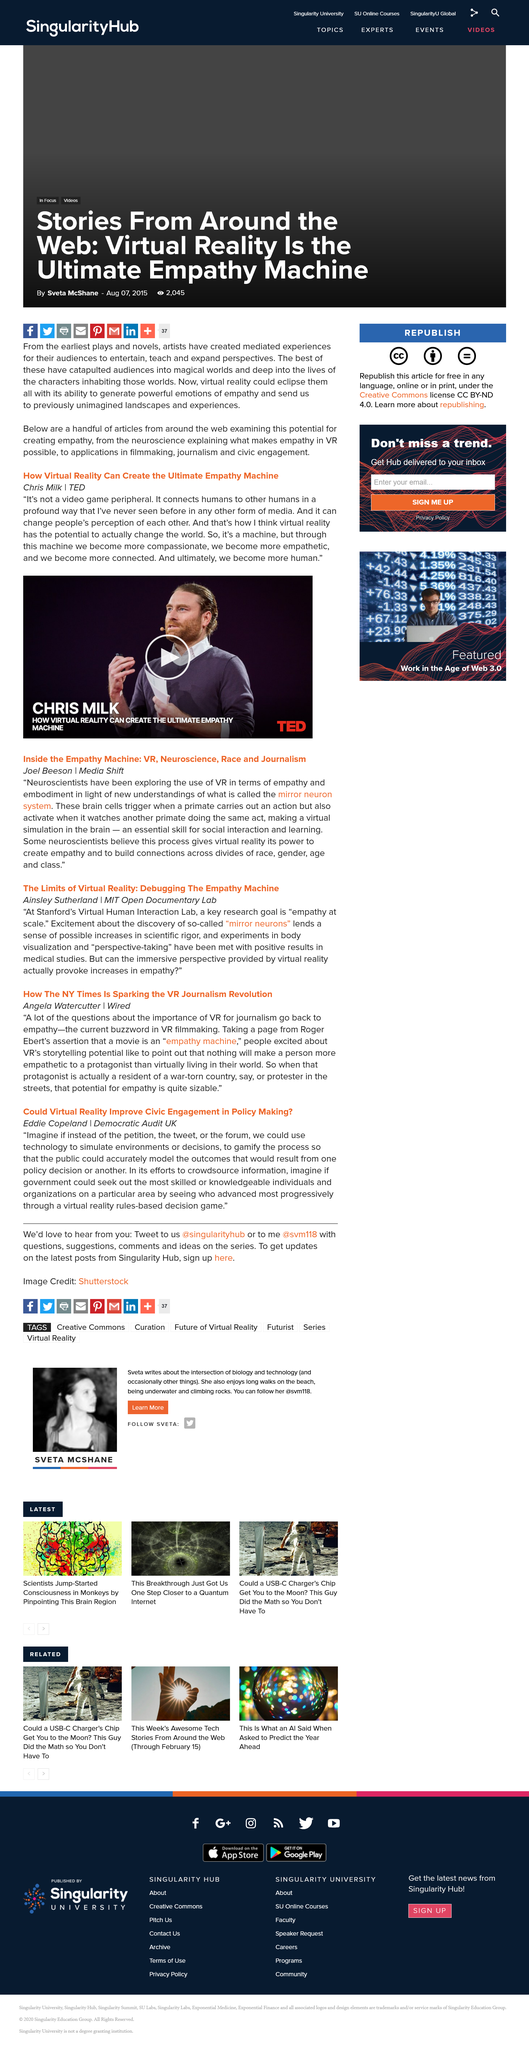List a handful of essential elements in this visual. The author of this article is Eddi Copeland. The name of the person in the video is Chris Milk. Chris Milk gave a talk at TED and did give a talk at TED. This article is titled "How Virtual Reality Can Create the Ultimate Empathy Machine" and explores the potential of virtual reality to foster empathy in individuals. Eddie Copeland is the Director of Democratic Audit UK, which is a leading independent organization that conducts research and provides analysis on the state of democracy in the United Kingdom. 